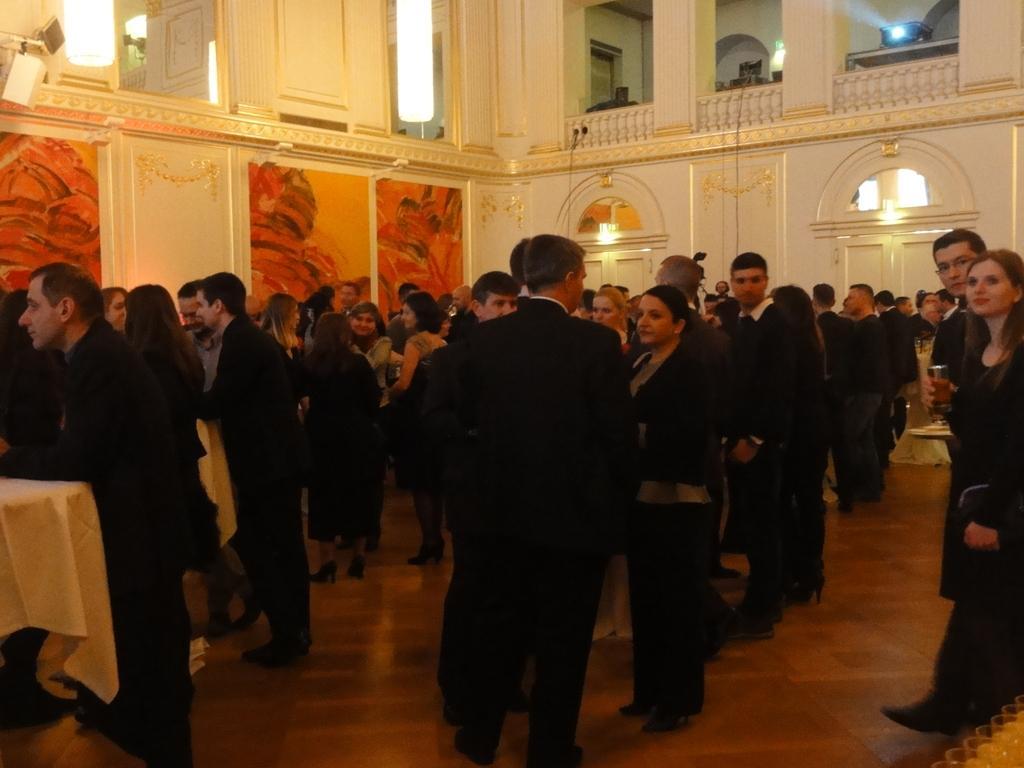Describe this image in one or two sentences. In this picture we can see a group of people standing on the floor and behind the people there is a wall with lights. 